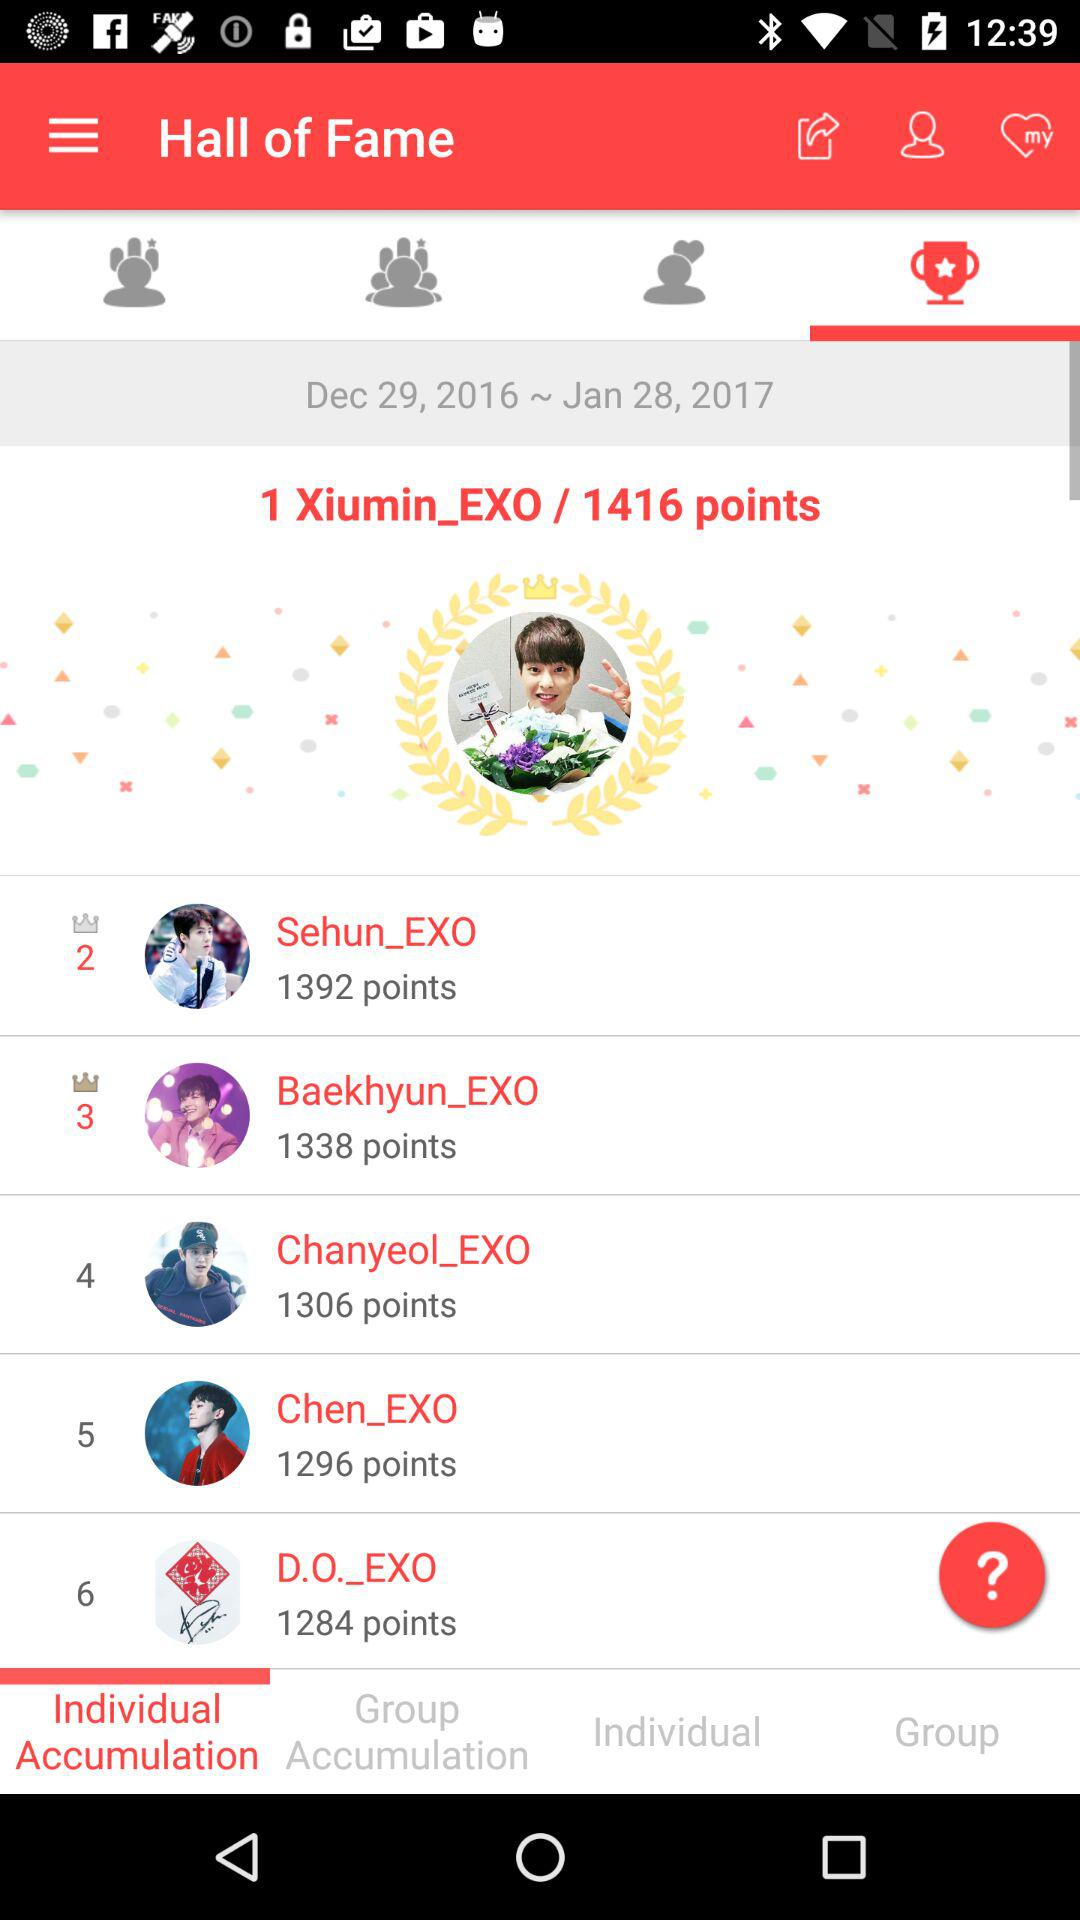What is the name of the application?
When the provided information is insufficient, respond with <no answer>. <no answer> 